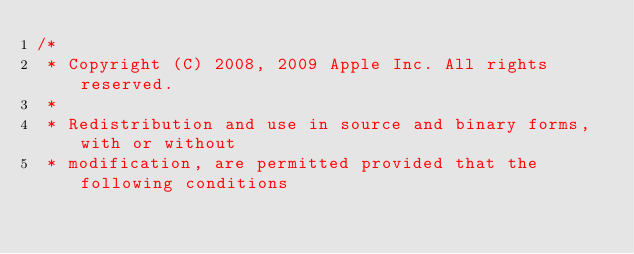<code> <loc_0><loc_0><loc_500><loc_500><_ObjectiveC_>/*
 * Copyright (C) 2008, 2009 Apple Inc. All rights reserved.
 *
 * Redistribution and use in source and binary forms, with or without
 * modification, are permitted provided that the following conditions</code> 